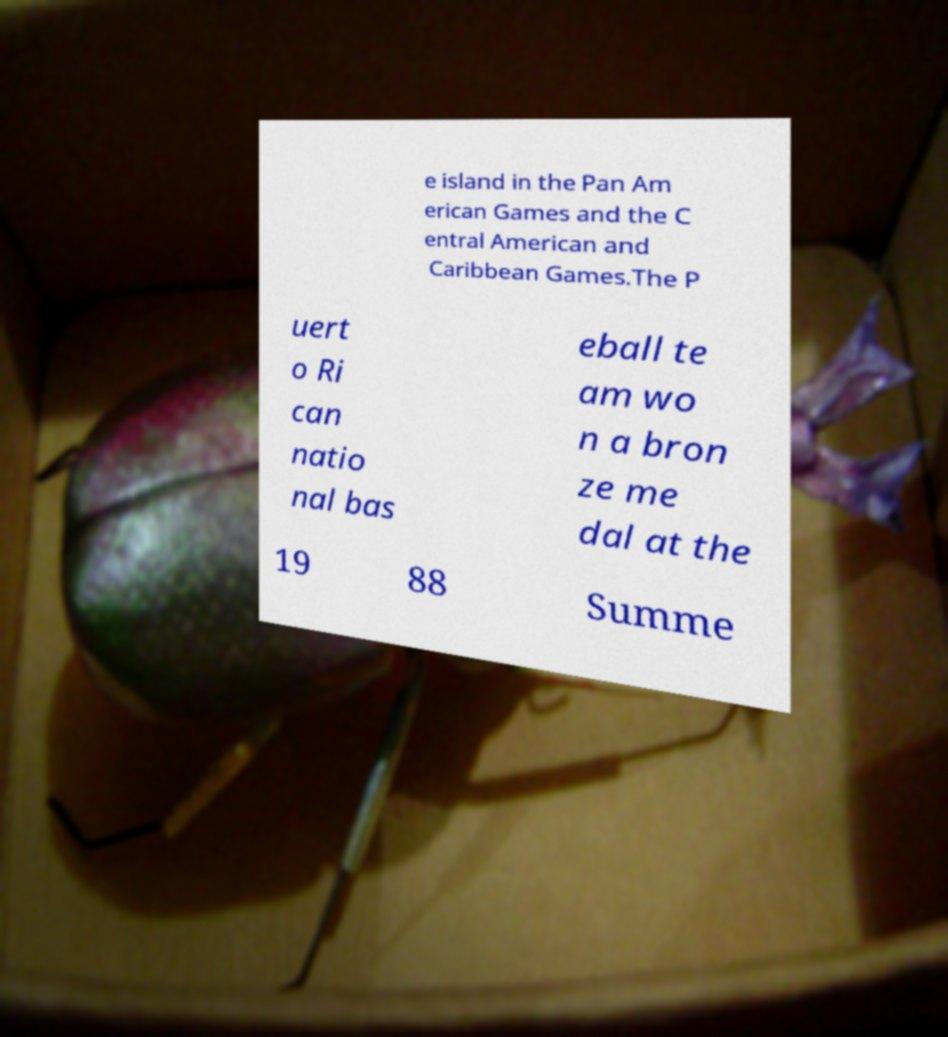Can you read and provide the text displayed in the image?This photo seems to have some interesting text. Can you extract and type it out for me? e island in the Pan Am erican Games and the C entral American and Caribbean Games.The P uert o Ri can natio nal bas eball te am wo n a bron ze me dal at the 19 88 Summe 